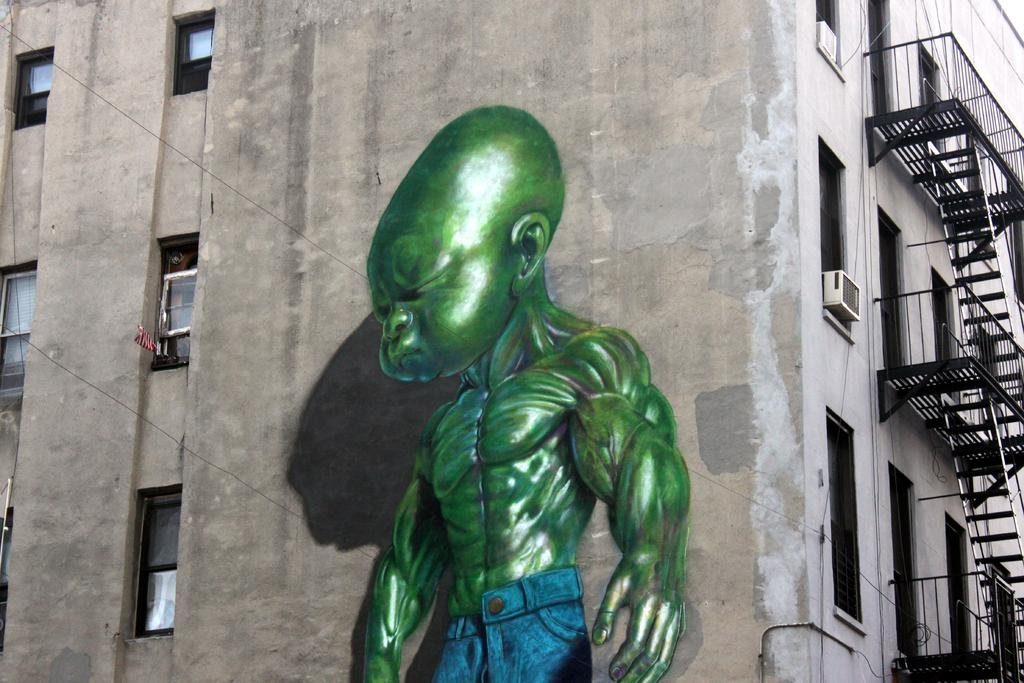What type of structure is visible in the image? There is a building in the image. What features can be seen on the building? The building has windows, staircases, and railings. What device is present to regulate temperature in the image? There is an air conditioner in the image. Is there any representation of a person in the image? There is an object that resembles a person in the image. What type of reaction does the sock have to the twist in the image? There is no sock present in the image, so it cannot have a reaction to any twist. 